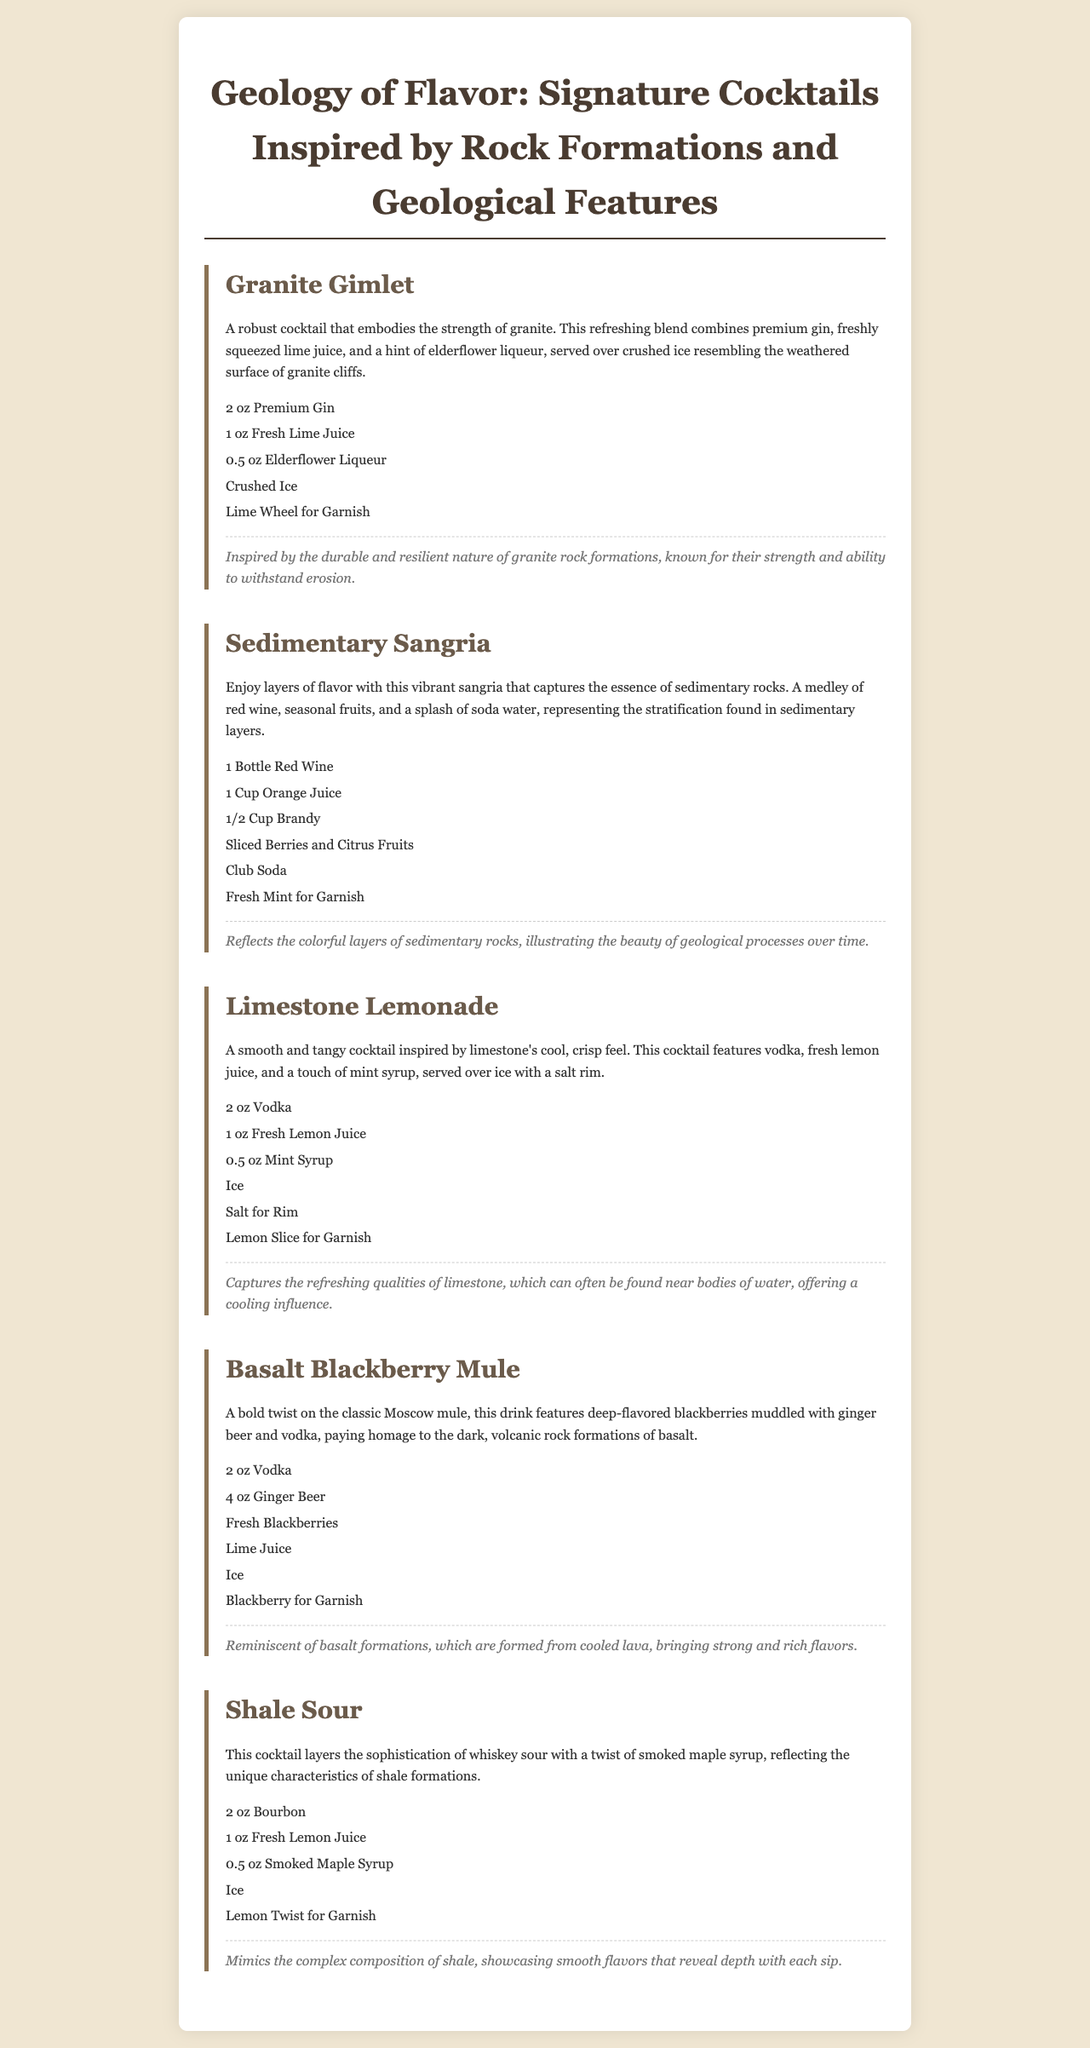What is the first cocktail listed? The first cocktail mentioned in the document is "Granite Gimlet."
Answer: Granite Gimlet How many ounces of vodka are used in the Limestone Lemonade? The recipe for Limestone Lemonade specifies 2 ounces of vodka.
Answer: 2 oz What is the garnish for the Shale Sour? The Shale Sour cocktail is garnished with a lemon twist.
Answer: Lemon Twist Which ingredient signifies the stratification in the Sedimentary Sangria? The Sedimentary Sangria represents stratification with seasonal fruits.
Answer: Seasonal fruits What unique ingredient is included in the Shale Sour? The Shale Sour includes smoked maple syrup as a unique ingredient.
Answer: Smoked Maple Syrup How many cocktails are inspired by volcanic rock formations? There is one cocktail inspired by volcanic rock formations, which is the Basalt Blackberry Mule.
Answer: One What type of gin is used in the Granite Gimlet? The Granite Gimlet features premium gin in its recipe.
Answer: Premium Gin What does the Limestone Lemonade capture the qualities of? The Limestone Lemonade captures the refreshing qualities of limestone.
Answer: Limestone What elements does the Basalt Blackberry Mule pay homage to? The Basalt Blackberry Mule pays homage to dark, volcanic rock formations.
Answer: Volcanic rock formations 